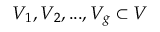<formula> <loc_0><loc_0><loc_500><loc_500>V _ { 1 } , V _ { 2 } , \dots , V _ { g } \subset V</formula> 